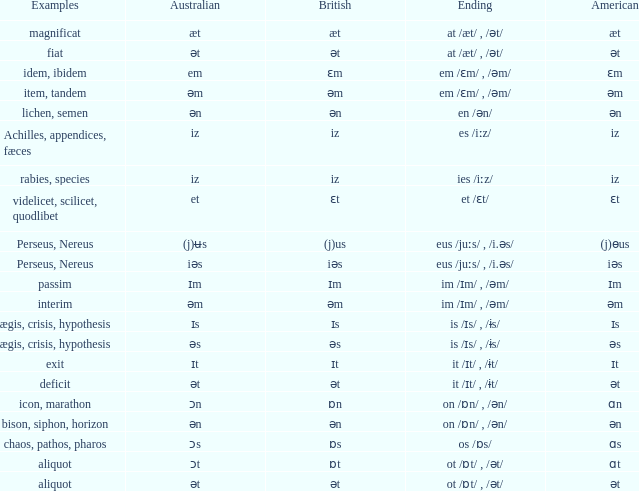Which Examples has Australian of əm? Item, tandem, interim. Can you give me this table as a dict? {'header': ['Examples', 'Australian', 'British', 'Ending', 'American'], 'rows': [['magnificat', 'æt', 'æt', 'at /æt/ , /ət/', 'æt'], ['fiat', 'ət', 'ət', 'at /æt/ , /ət/', 'ət'], ['idem, ibidem', 'em', 'ɛm', 'em /ɛm/ , /əm/', 'ɛm'], ['item, tandem', 'əm', 'əm', 'em /ɛm/ , /əm/', 'əm'], ['lichen, semen', 'ən', 'ən', 'en /ən/', 'ən'], ['Achilles, appendices, fæces', 'iz', 'iz', 'es /iːz/', 'iz'], ['rabies, species', 'iz', 'iz', 'ies /iːz/', 'iz'], ['videlicet, scilicet, quodlibet', 'et', 'ɛt', 'et /ɛt/', 'ɛt'], ['Perseus, Nereus', '(j)ʉs', '(j)us', 'eus /juːs/ , /i.əs/', '(j)ɵus'], ['Perseus, Nereus', 'iəs', 'iəs', 'eus /juːs/ , /i.əs/', 'iəs'], ['passim', 'ɪm', 'ɪm', 'im /ɪm/ , /əm/', 'ɪm'], ['interim', 'əm', 'əm', 'im /ɪm/ , /əm/', 'əm'], ['ægis, crisis, hypothesis', 'ɪs', 'ɪs', 'is /ɪs/ , /ɨs/', 'ɪs'], ['ægis, crisis, hypothesis', 'əs', 'əs', 'is /ɪs/ , /ɨs/', 'əs'], ['exit', 'ɪt', 'ɪt', 'it /ɪt/ , /ɨt/', 'ɪt'], ['deficit', 'ət', 'ət', 'it /ɪt/ , /ɨt/', 'ət'], ['icon, marathon', 'ɔn', 'ɒn', 'on /ɒn/ , /ən/', 'ɑn'], ['bison, siphon, horizon', 'ən', 'ən', 'on /ɒn/ , /ən/', 'ən'], ['chaos, pathos, pharos', 'ɔs', 'ɒs', 'os /ɒs/', 'ɑs'], ['aliquot', 'ɔt', 'ɒt', 'ot /ɒt/ , /ət/', 'ɑt'], ['aliquot', 'ət', 'ət', 'ot /ɒt/ , /ət/', 'ət']]} 